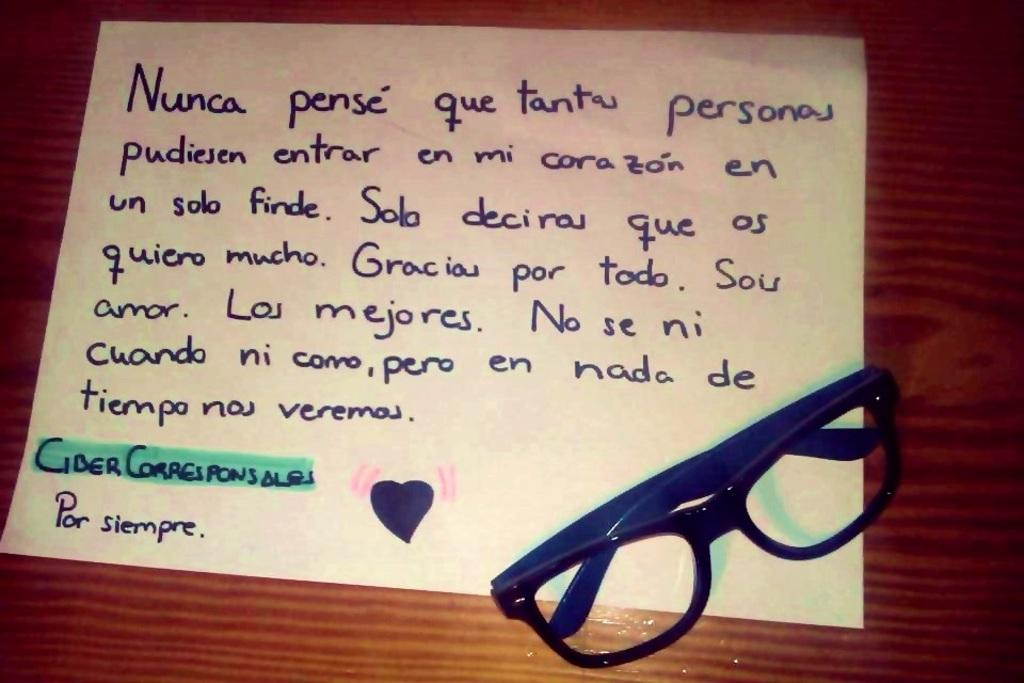What type of table is in the image? There is a wooden table in the image. What is on top of the table? There is a paper and a pair of spectacles on the table. What is written on the paper? There is writing on the paper. What type of vessel is used to transport the spectacles in the image? There is no vessel present in the image, and the spectacles are already on the table. 